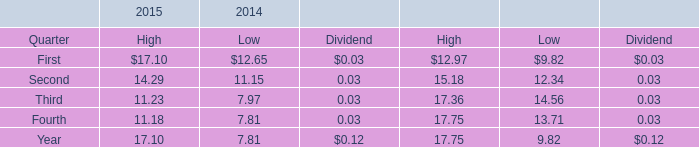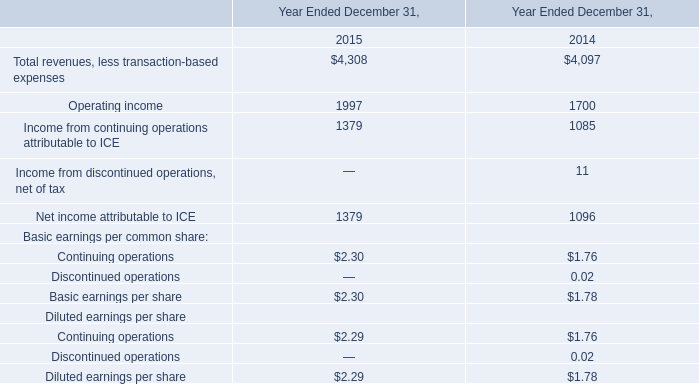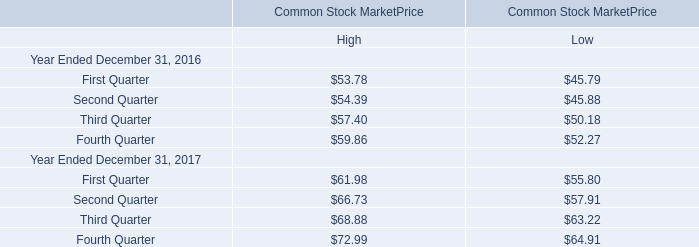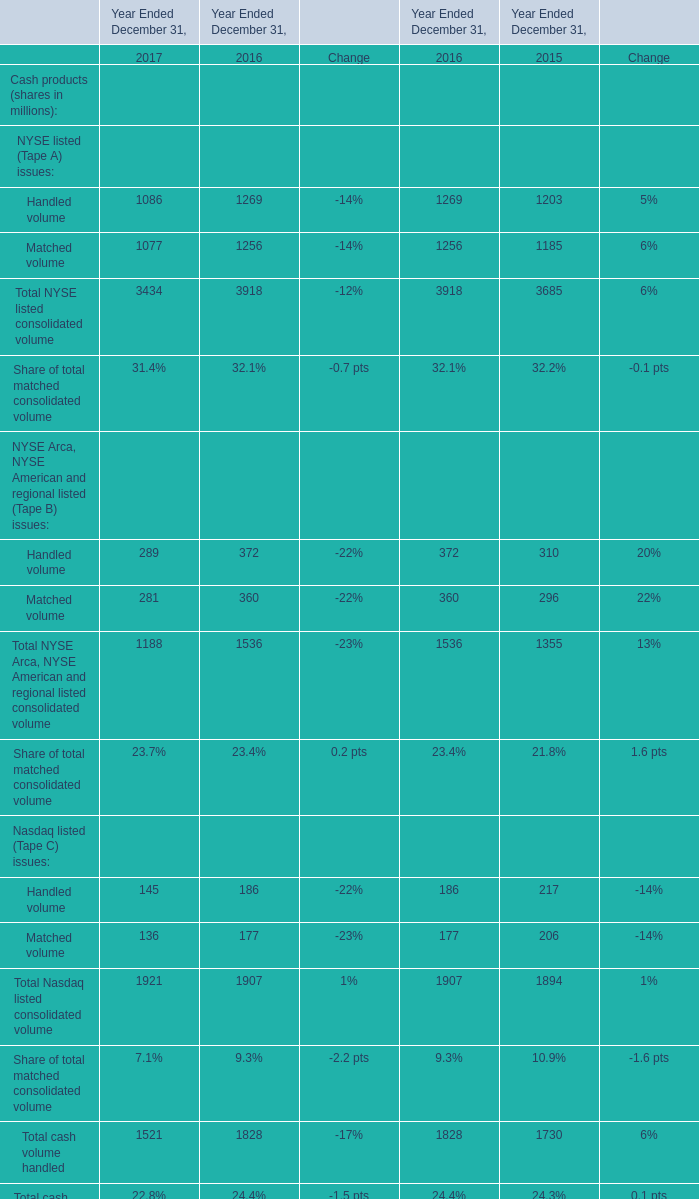What was the average of the Handled volume in the years where Handled volume is positive? 
Computations: (((289 + 372) + 310) / 3)
Answer: 323.66667. 